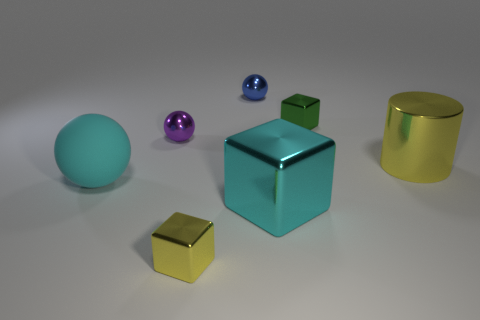Subtract all shiny balls. How many balls are left? 1 Add 2 matte things. How many objects exist? 9 Subtract all red blocks. Subtract all yellow spheres. How many blocks are left? 3 Subtract all rubber cylinders. Subtract all yellow blocks. How many objects are left? 6 Add 7 green metal blocks. How many green metal blocks are left? 8 Add 6 purple metal spheres. How many purple metal spheres exist? 7 Subtract 0 brown cylinders. How many objects are left? 7 Subtract all balls. How many objects are left? 4 